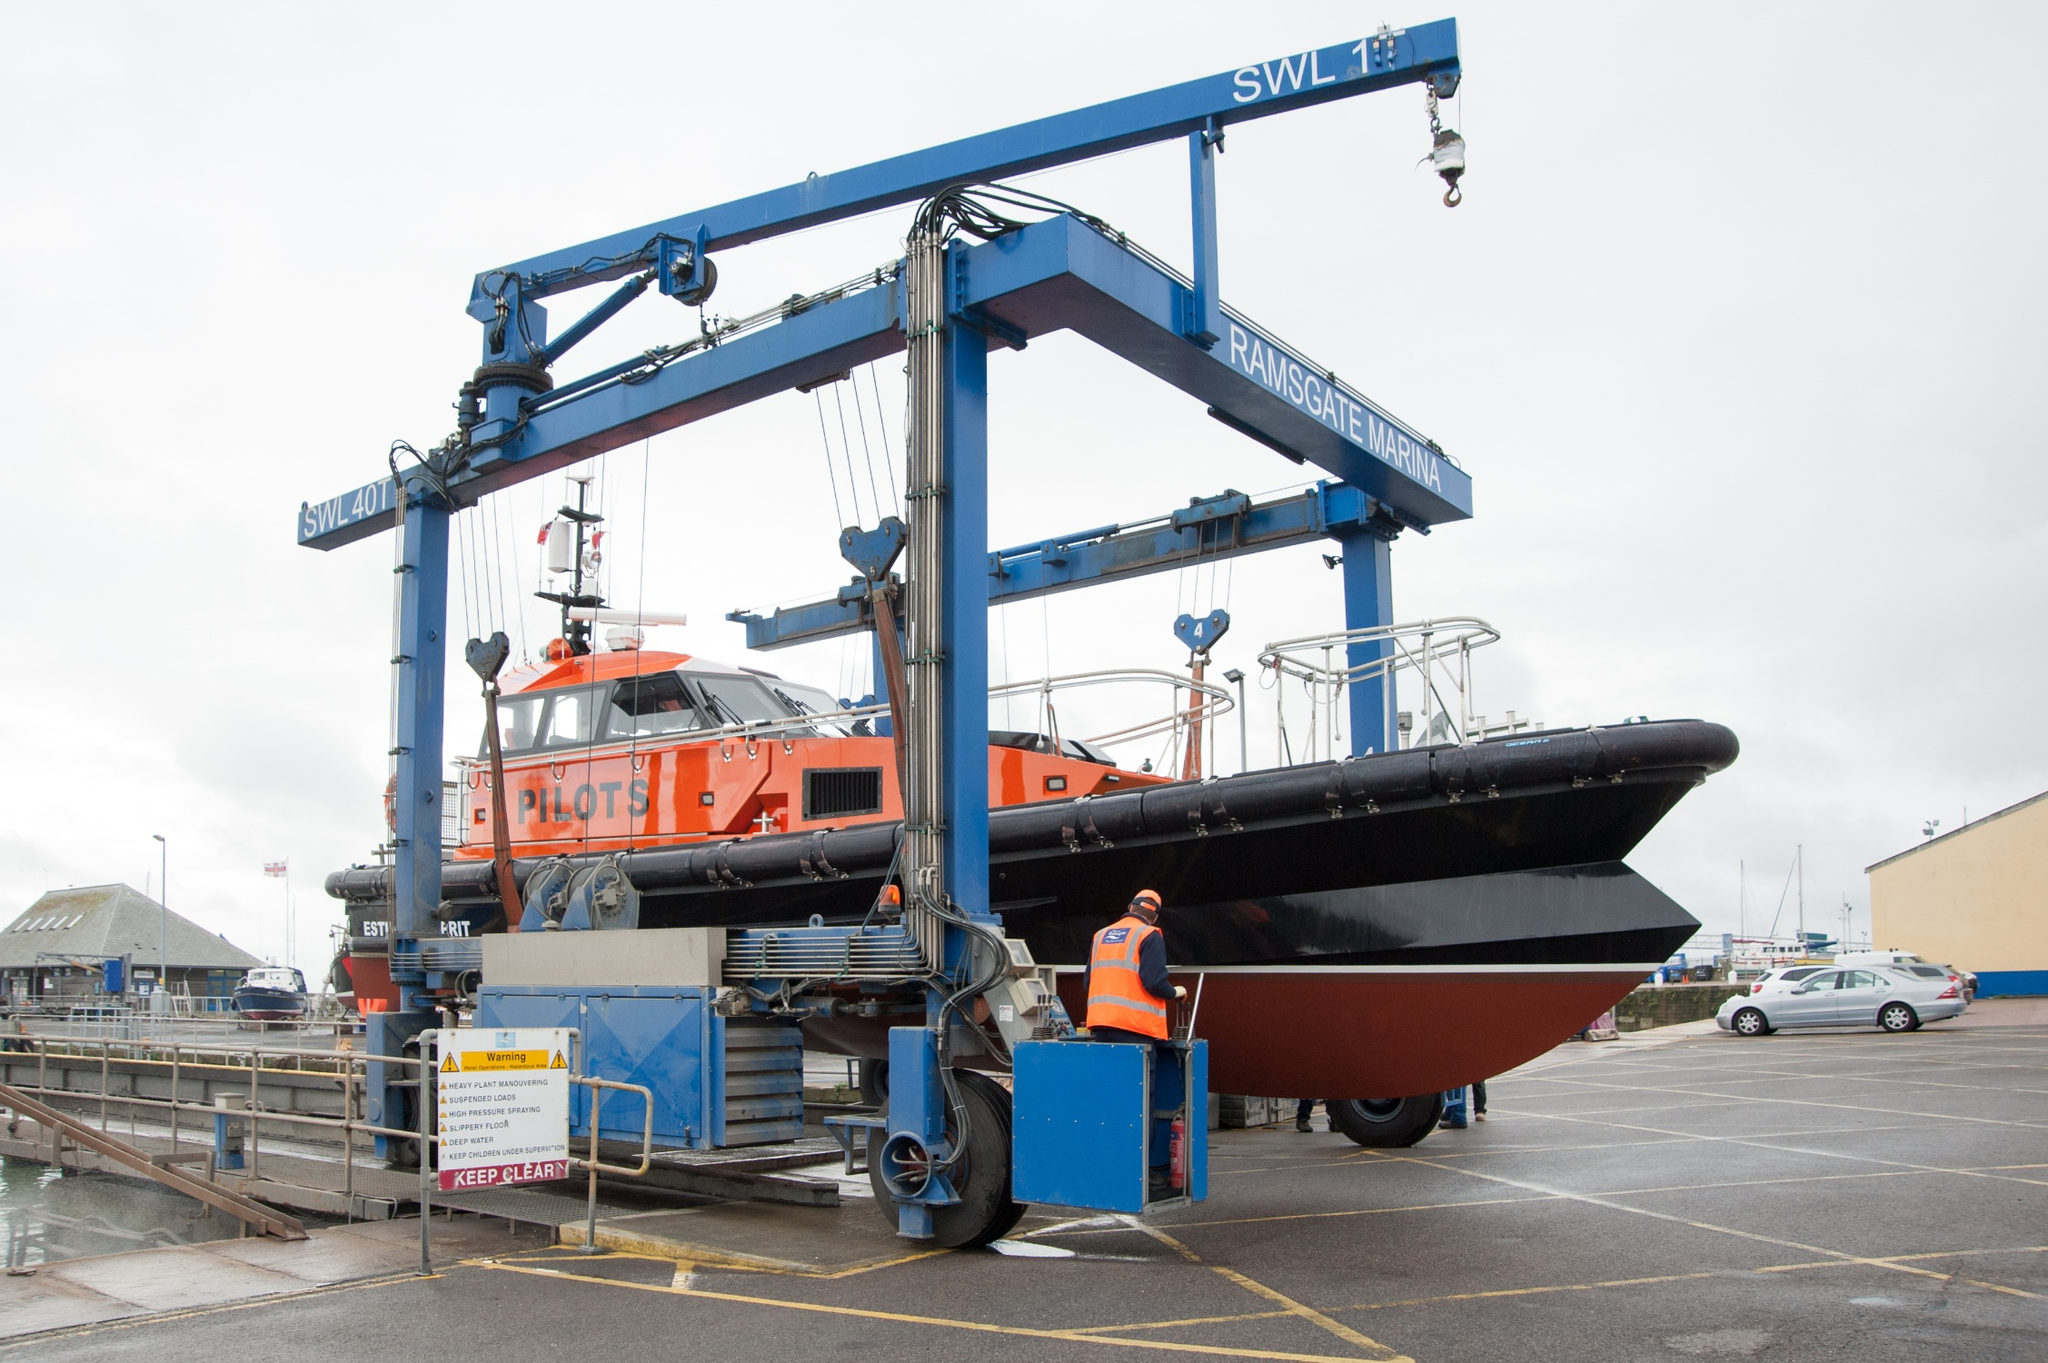Can you explain the function of the crane and why it might be used in this scenario? The crane is specifically designed for lifting heavy objects at marinas, such as boats and other marine equipment, which are too large or heavy to be handled by standard methods. In this scenario, the crane is used to lift a pilot boat out of the water for maintenance or storage purposes, helping prevent wear and tear from prolonged water exposure. 